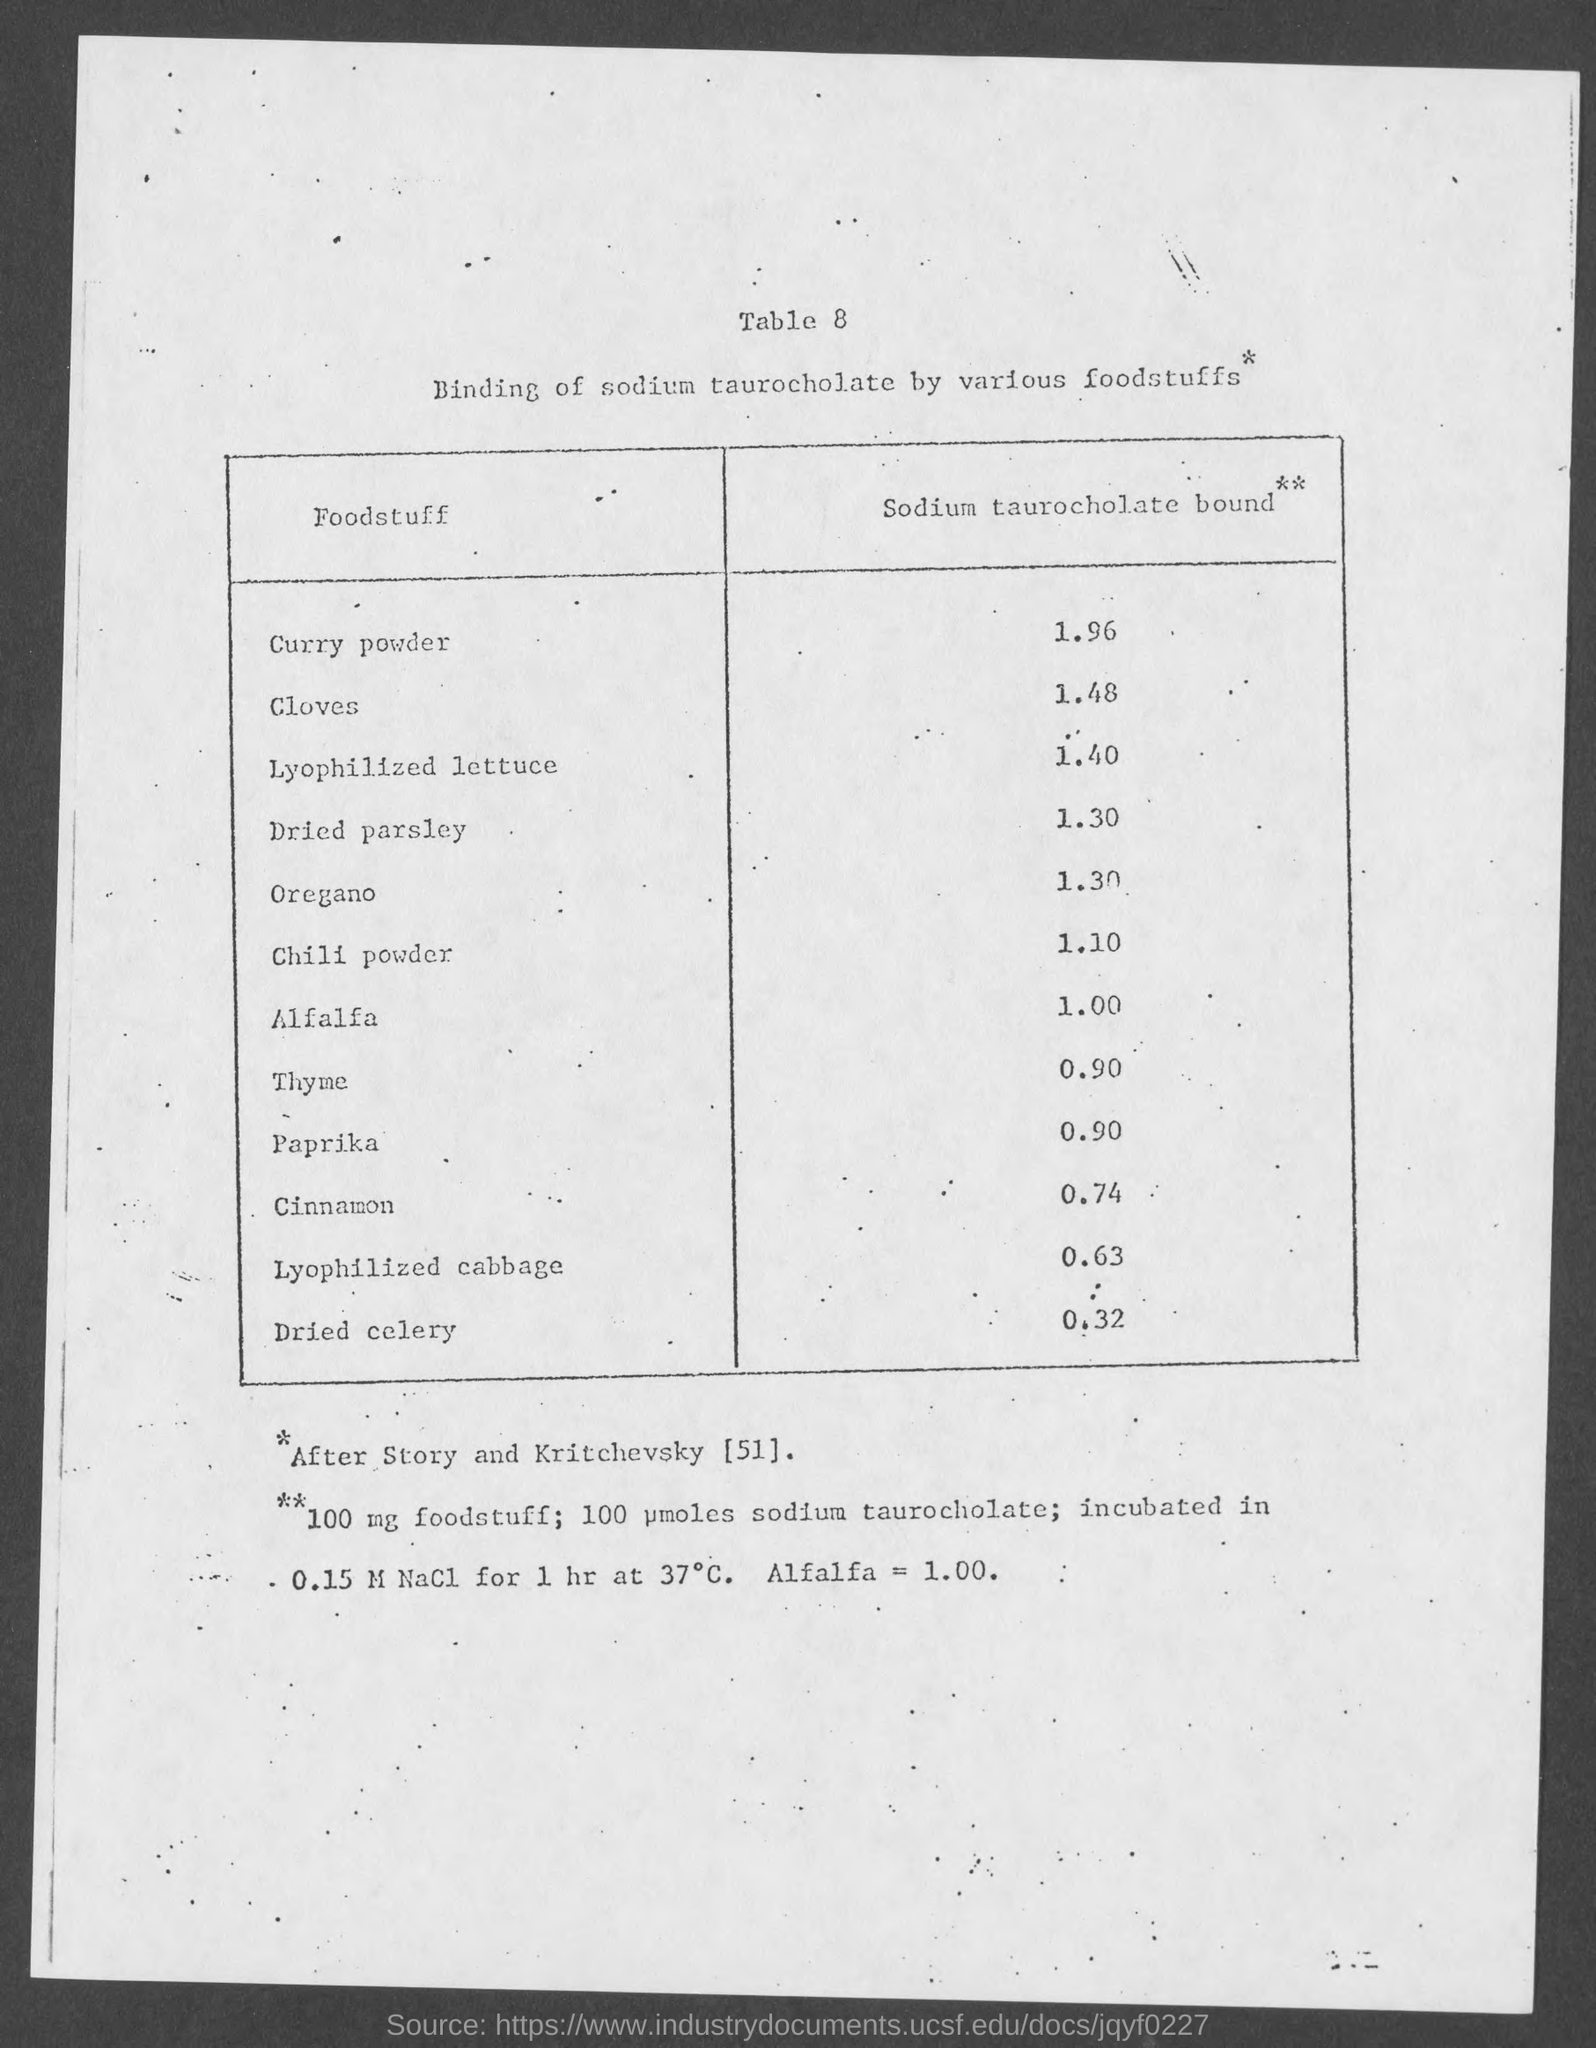What is the value of Sodium taurocholate bound in cloves?
Provide a succinct answer. 1.48. Which foodstuff has a value of 1.00 Sodium taurocholate bound?
Offer a terse response. Alfalfa. 